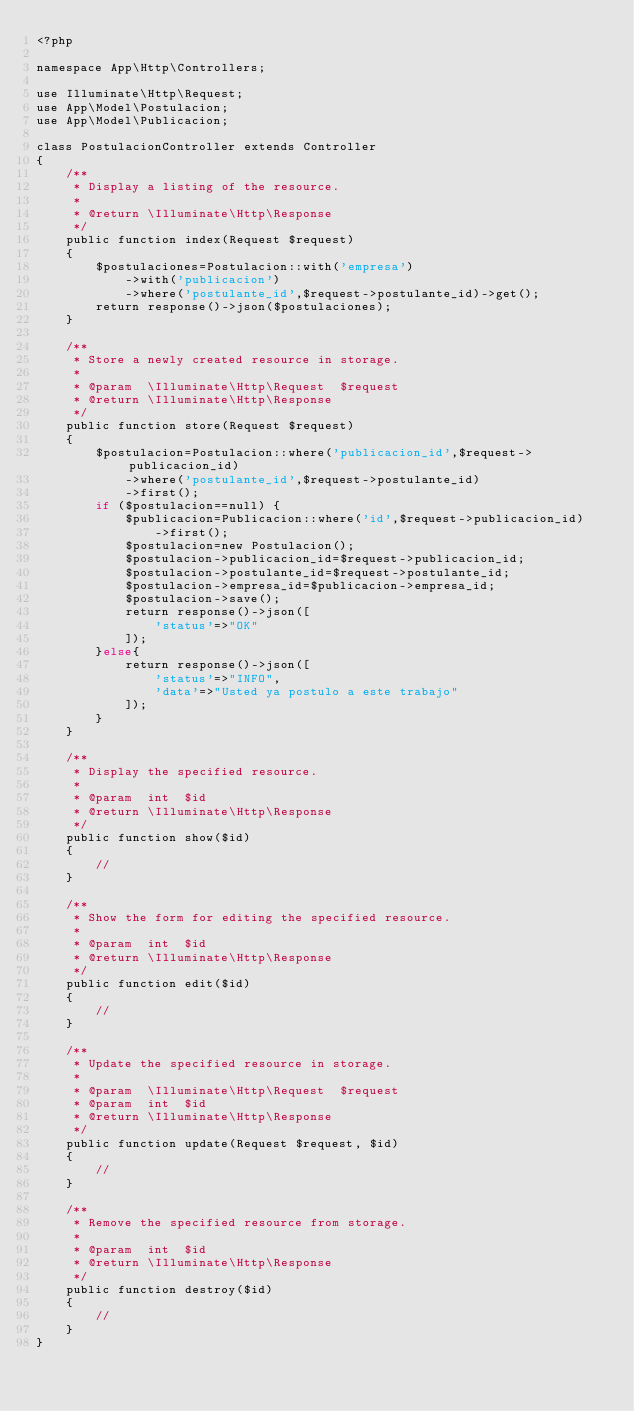Convert code to text. <code><loc_0><loc_0><loc_500><loc_500><_PHP_><?php

namespace App\Http\Controllers;

use Illuminate\Http\Request;
use App\Model\Postulacion;
use App\Model\Publicacion;

class PostulacionController extends Controller
{
    /**
     * Display a listing of the resource.
     *
     * @return \Illuminate\Http\Response
     */
    public function index(Request $request)
    {
        $postulaciones=Postulacion::with('empresa')
            ->with('publicacion')
            ->where('postulante_id',$request->postulante_id)->get();
        return response()->json($postulaciones);
    }

    /**
     * Store a newly created resource in storage.
     *
     * @param  \Illuminate\Http\Request  $request
     * @return \Illuminate\Http\Response
     */
    public function store(Request $request)
    {
        $postulacion=Postulacion::where('publicacion_id',$request->publicacion_id)
            ->where('postulante_id',$request->postulante_id)
            ->first();
        if ($postulacion==null) {
            $publicacion=Publicacion::where('id',$request->publicacion_id)
                ->first();
            $postulacion=new Postulacion();
            $postulacion->publicacion_id=$request->publicacion_id;
            $postulacion->postulante_id=$request->postulante_id;
            $postulacion->empresa_id=$publicacion->empresa_id;
            $postulacion->save();
            return response()->json([
                'status'=>"OK"
            ]);
        }else{
            return response()->json([
                'status'=>"INFO",
                'data'=>"Usted ya postulo a este trabajo"
            ]);
        }
    }

    /**
     * Display the specified resource.
     *
     * @param  int  $id
     * @return \Illuminate\Http\Response
     */
    public function show($id)
    {
        //
    }

    /**
     * Show the form for editing the specified resource.
     *
     * @param  int  $id
     * @return \Illuminate\Http\Response
     */
    public function edit($id)
    {
        //
    }

    /**
     * Update the specified resource in storage.
     *
     * @param  \Illuminate\Http\Request  $request
     * @param  int  $id
     * @return \Illuminate\Http\Response
     */
    public function update(Request $request, $id)
    {
        //
    }

    /**
     * Remove the specified resource from storage.
     *
     * @param  int  $id
     * @return \Illuminate\Http\Response
     */
    public function destroy($id)
    {
        //
    }
}
</code> 